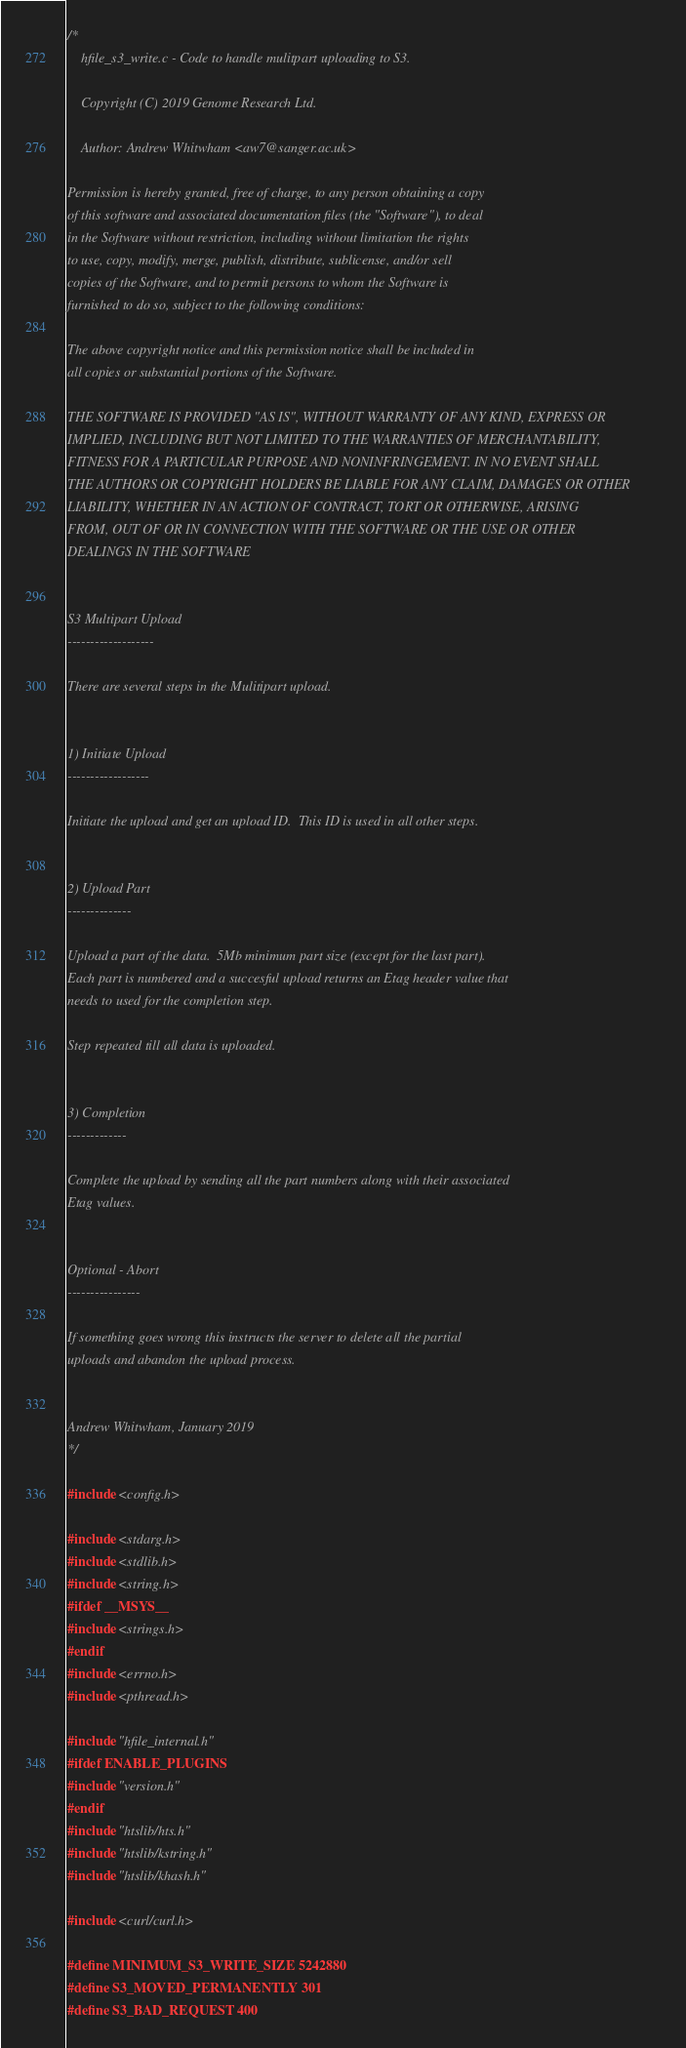Convert code to text. <code><loc_0><loc_0><loc_500><loc_500><_C_>/*
    hfile_s3_write.c - Code to handle mulitpart uploading to S3.

    Copyright (C) 2019 Genome Research Ltd.

    Author: Andrew Whitwham <aw7@sanger.ac.uk>

Permission is hereby granted, free of charge, to any person obtaining a copy
of this software and associated documentation files (the "Software"), to deal
in the Software without restriction, including without limitation the rights
to use, copy, modify, merge, publish, distribute, sublicense, and/or sell
copies of the Software, and to permit persons to whom the Software is
furnished to do so, subject to the following conditions:

The above copyright notice and this permission notice shall be included in
all copies or substantial portions of the Software.

THE SOFTWARE IS PROVIDED "AS IS", WITHOUT WARRANTY OF ANY KIND, EXPRESS OR
IMPLIED, INCLUDING BUT NOT LIMITED TO THE WARRANTIES OF MERCHANTABILITY,
FITNESS FOR A PARTICULAR PURPOSE AND NONINFRINGEMENT. IN NO EVENT SHALL
THE AUTHORS OR COPYRIGHT HOLDERS BE LIABLE FOR ANY CLAIM, DAMAGES OR OTHER
LIABILITY, WHETHER IN AN ACTION OF CONTRACT, TORT OR OTHERWISE, ARISING
FROM, OUT OF OR IN CONNECTION WITH THE SOFTWARE OR THE USE OR OTHER
DEALINGS IN THE SOFTWARE


S3 Multipart Upload
-------------------

There are several steps in the Mulitipart upload.


1) Initiate Upload
------------------

Initiate the upload and get an upload ID.  This ID is used in all other steps.


2) Upload Part
--------------

Upload a part of the data.  5Mb minimum part size (except for the last part).
Each part is numbered and a succesful upload returns an Etag header value that
needs to used for the completion step.

Step repeated till all data is uploaded.


3) Completion
-------------

Complete the upload by sending all the part numbers along with their associated
Etag values.


Optional - Abort
----------------

If something goes wrong this instructs the server to delete all the partial
uploads and abandon the upload process.


Andrew Whitwham, January 2019
*/

#include <config.h>

#include <stdarg.h>
#include <stdlib.h>
#include <string.h>
#ifdef __MSYS__
#include <strings.h>
#endif
#include <errno.h>
#include <pthread.h>

#include "hfile_internal.h"
#ifdef ENABLE_PLUGINS
#include "version.h"
#endif
#include "htslib/hts.h"
#include "htslib/kstring.h"
#include "htslib/khash.h"

#include <curl/curl.h>

#define MINIMUM_S3_WRITE_SIZE 5242880
#define S3_MOVED_PERMANENTLY 301
#define S3_BAD_REQUEST 400
</code> 